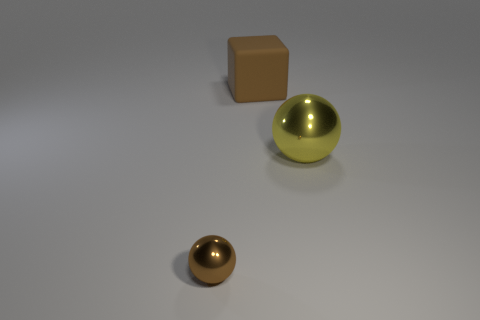Add 2 tiny brown things. How many objects exist? 5 Subtract all blocks. How many objects are left? 2 Add 3 metal balls. How many metal balls are left? 5 Add 1 metal spheres. How many metal spheres exist? 3 Subtract 0 cyan blocks. How many objects are left? 3 Subtract all large shiny things. Subtract all brown spheres. How many objects are left? 1 